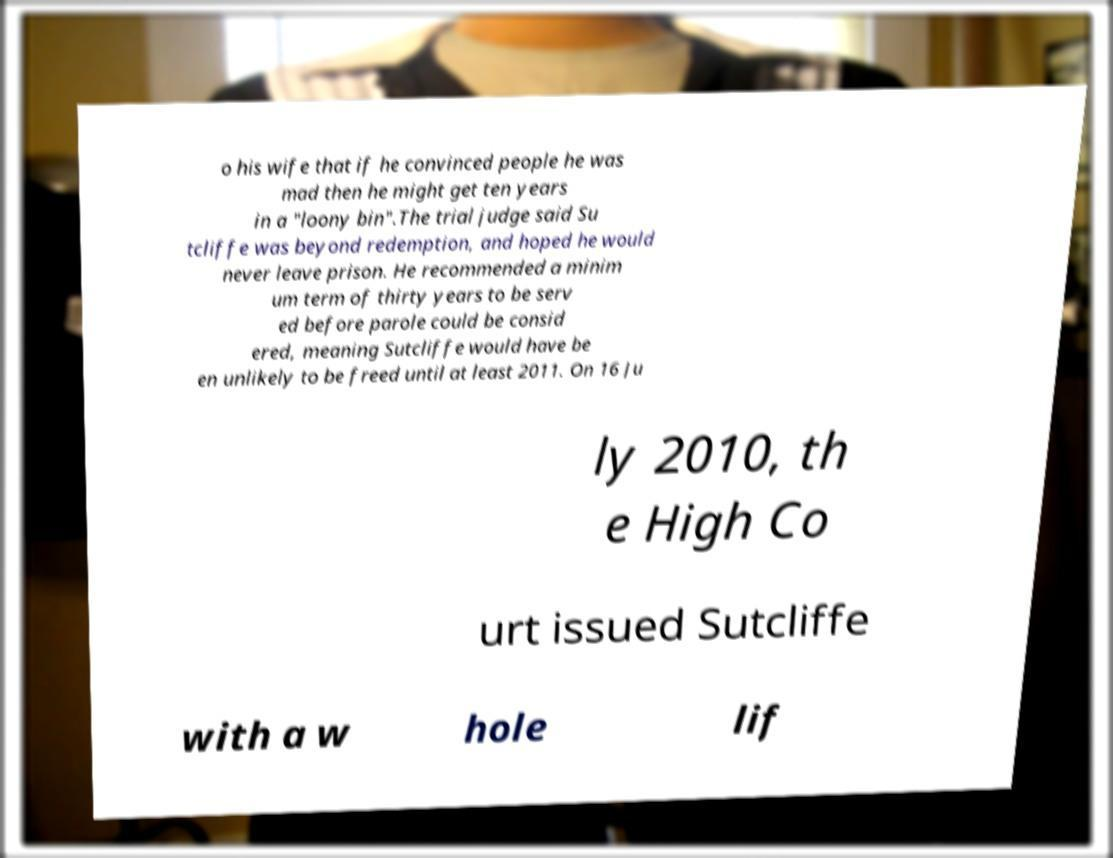Please read and relay the text visible in this image. What does it say? o his wife that if he convinced people he was mad then he might get ten years in a "loony bin".The trial judge said Su tcliffe was beyond redemption, and hoped he would never leave prison. He recommended a minim um term of thirty years to be serv ed before parole could be consid ered, meaning Sutcliffe would have be en unlikely to be freed until at least 2011. On 16 Ju ly 2010, th e High Co urt issued Sutcliffe with a w hole lif 